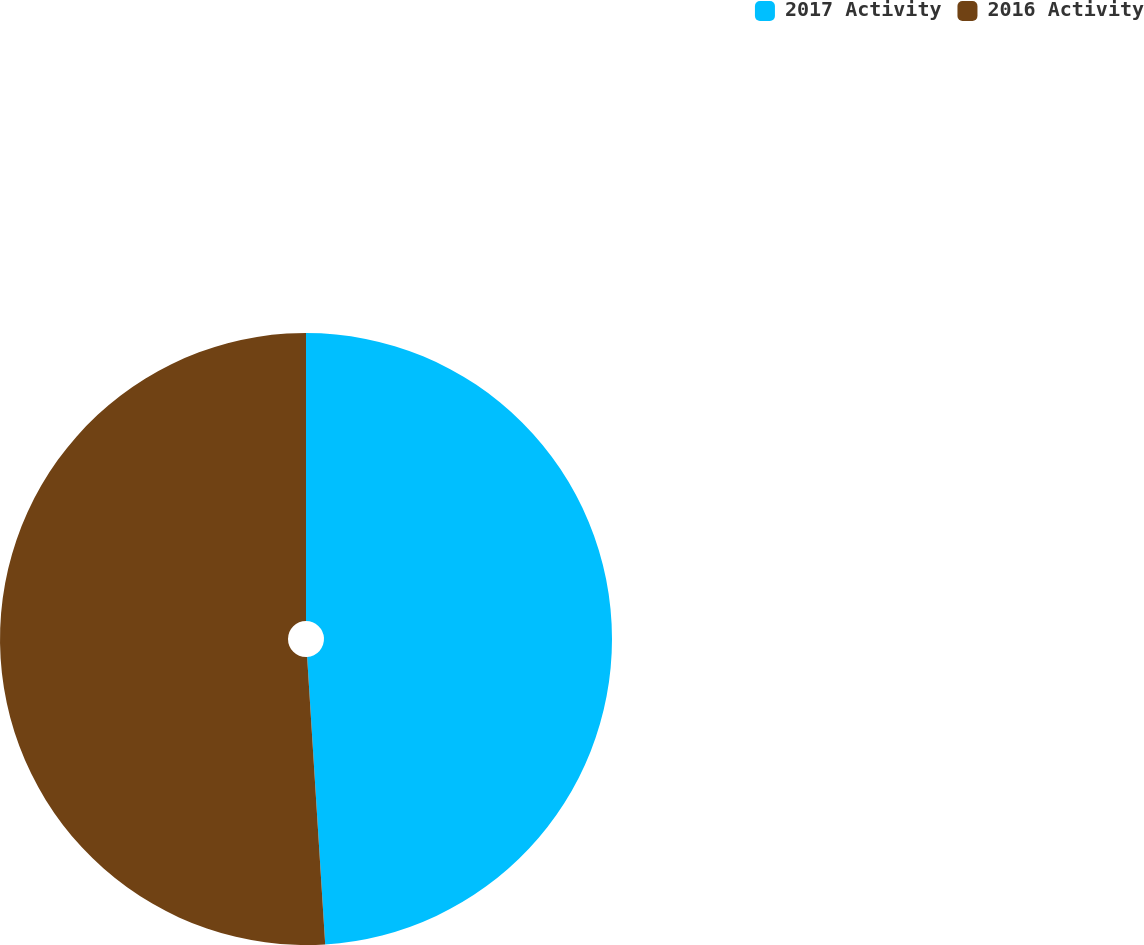Convert chart. <chart><loc_0><loc_0><loc_500><loc_500><pie_chart><fcel>2017 Activity<fcel>2016 Activity<nl><fcel>49.0%<fcel>51.0%<nl></chart> 